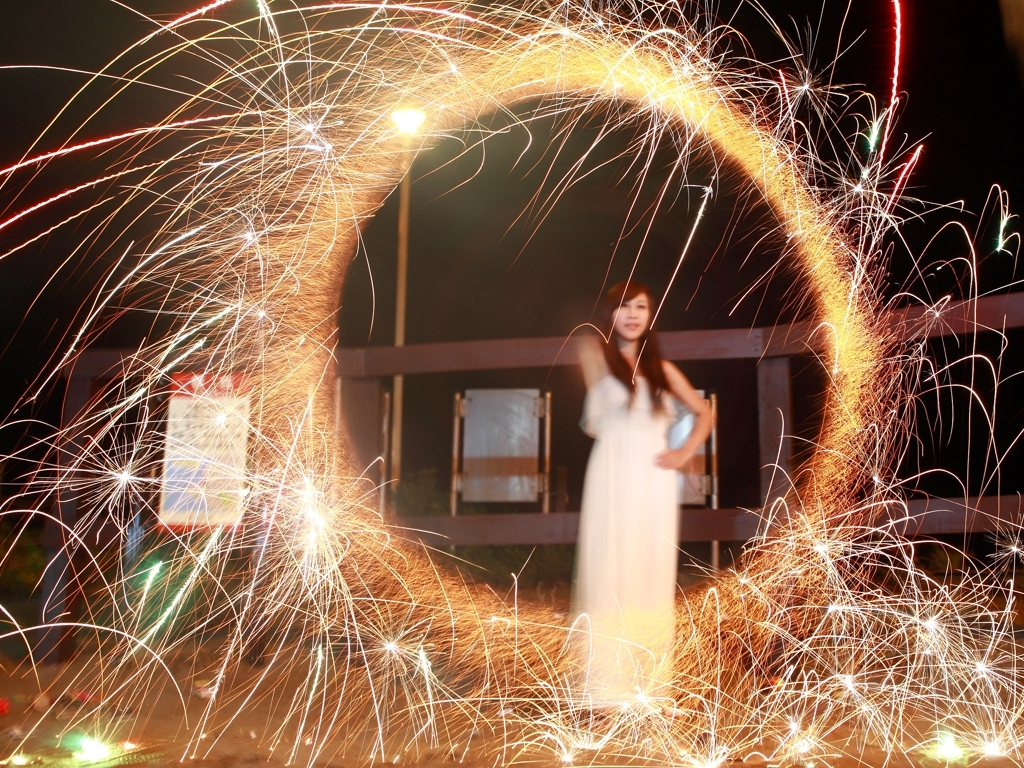How does the lighting technique in this photo contribute to its overall feel or atmosphere? The use of long exposure to create light trails adds a sense of motion and dynamism to the image. It introduces an element of fantasy and makes the scene more vibrant and energetic, contributing to a whimsical and almost magical atmosphere. 